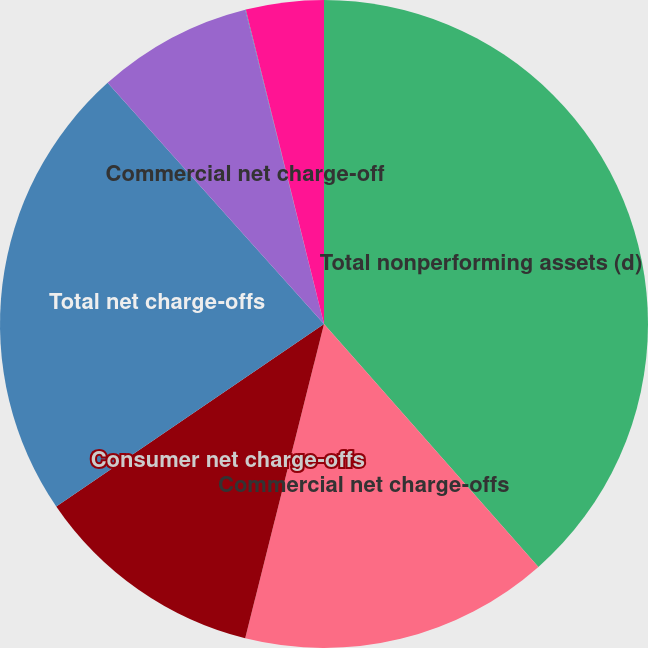Convert chart. <chart><loc_0><loc_0><loc_500><loc_500><pie_chart><fcel>Total nonperforming assets (d)<fcel>Commercial net charge-offs<fcel>Consumer net charge-offs<fcel>Total net charge-offs<fcel>Commercial net charge-off<fcel>Consumer net charge-off ratio<fcel>Total net charge-off ratio<nl><fcel>38.49%<fcel>15.42%<fcel>11.57%<fcel>22.88%<fcel>7.73%<fcel>0.03%<fcel>3.88%<nl></chart> 